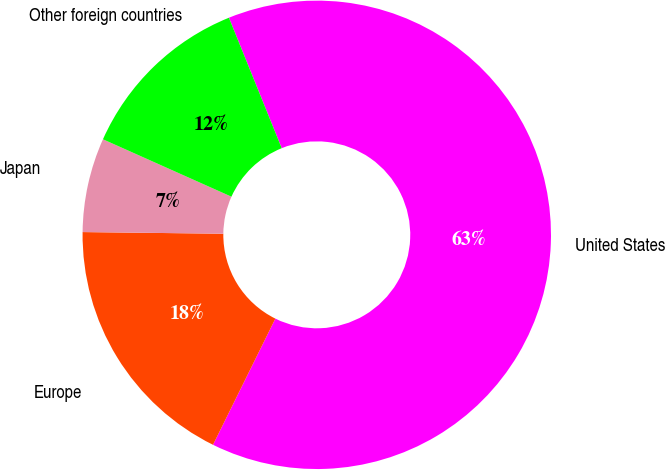<chart> <loc_0><loc_0><loc_500><loc_500><pie_chart><fcel>United States<fcel>Europe<fcel>Japan<fcel>Other foreign countries<nl><fcel>63.42%<fcel>17.88%<fcel>6.5%<fcel>12.19%<nl></chart> 